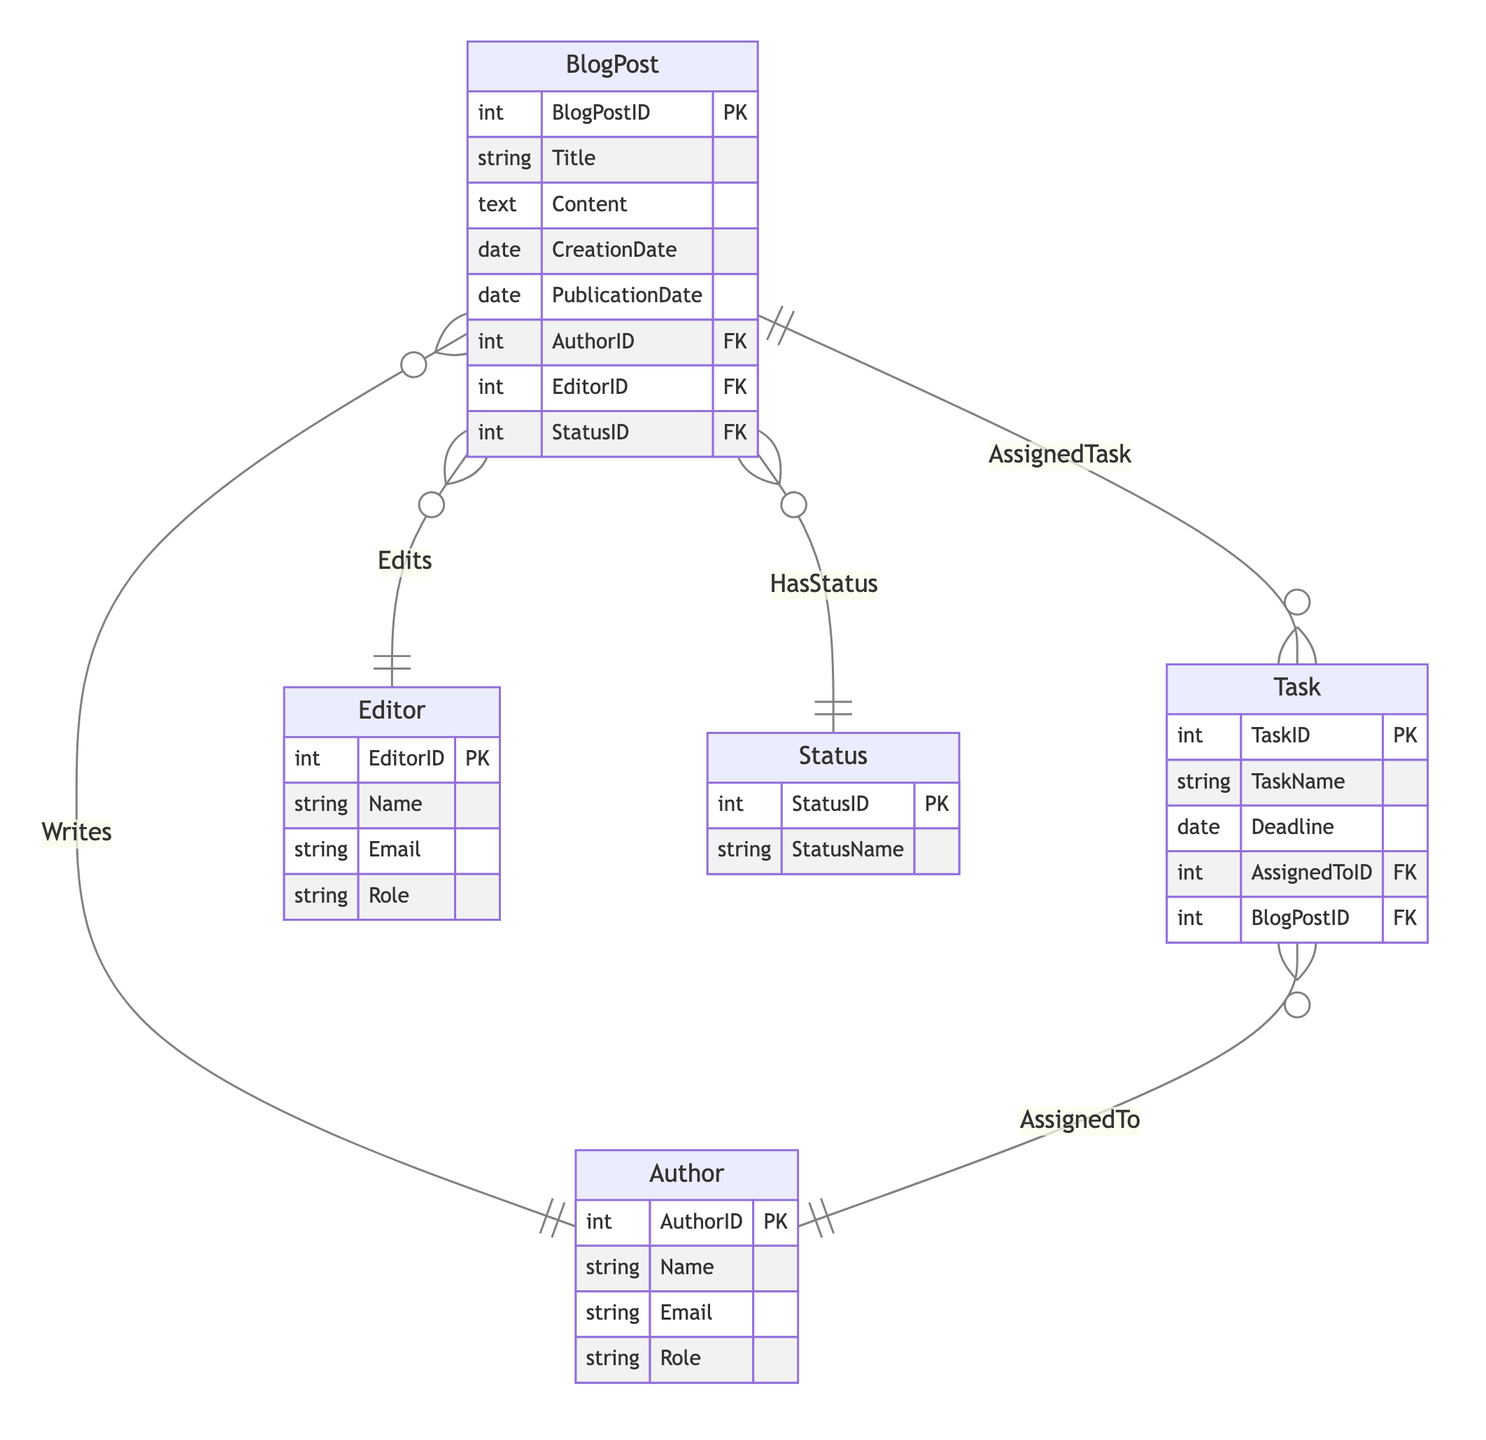What is the primary key of the BlogPost entity? The primary key of the BlogPost entity is BlogPostID, which uniquely identifies each blog post in the system.
Answer: BlogPostID How many attributes does the Author entity have? The Author entity has four attributes: AuthorID, Name, Email, and Role, which define the details for each author.
Answer: Four What type of relationship exists between Task and BlogPost? The relationship between Task and BlogPost is N:1, indicating that multiple tasks can be associated with a single blog post.
Answer: N:1 Which entity is responsible for editing a blog post? The Editor entity is responsible for editing a blog post, as indicated by the relationship labeled "Edits" in the diagram.
Answer: Editor How many possible statuses can a BlogPost have? A BlogPost can have multiple statuses, as indicated by the N:1 relationship with the Status entity, suggesting there may be many status types available.
Answer: Many What does the relationship "Writes" indicate? The "Writes" relationship indicates that one author can write multiple blog posts, which correlates to the 1:N relationship between Author and BlogPost.
Answer: One to many How many tasks can be assigned to a single blog post? A single blog post can have multiple tasks assigned to it based on the N:1 relationship indicated between Task and BlogPost, meaning many tasks can belong to a single blog post.
Answer: Many What is the foreign key in the Task entity associated with BlogPost? The foreign key in the Task entity associated with BlogPost is BlogPostID, which connects tasks to their respective blog post.
Answer: BlogPostID Who can be assigned tasks, according to the diagram? Authors can be assigned tasks, as indicated by the "AssignedTo" relationship demonstrating that tasks are connected to authors.
Answer: Authors 